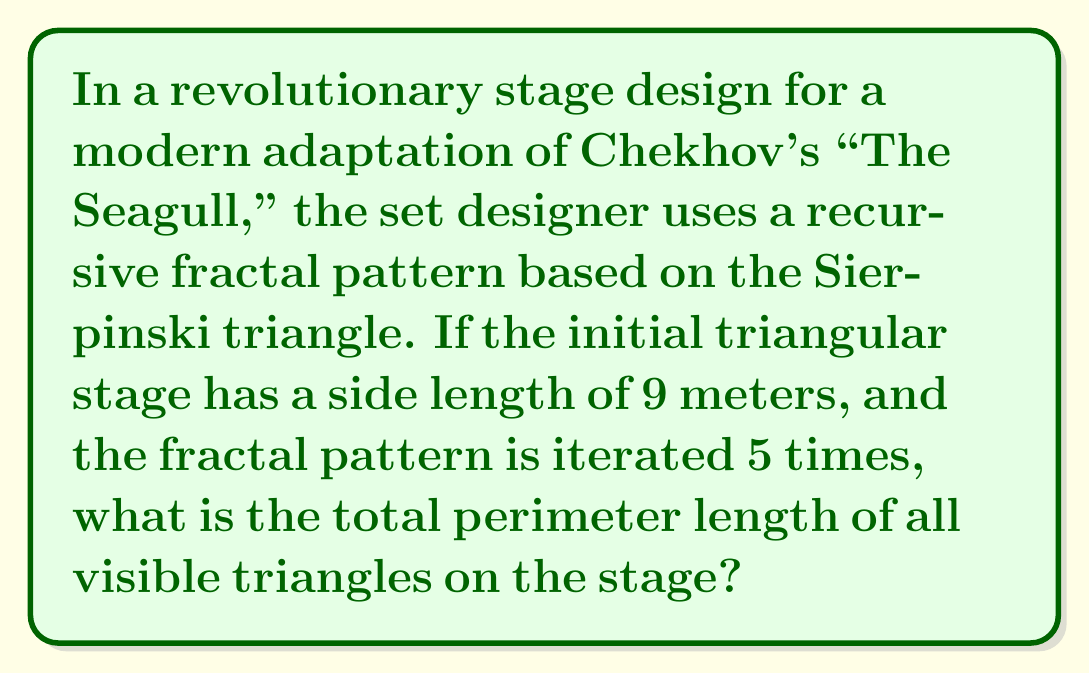Teach me how to tackle this problem. Let's approach this step-by-step:

1) The Sierpinski triangle is created by repeatedly removing the central triangle from each existing triangle.

2) In each iteration, the number of triangles triples, while their side length halves.

3) Let's calculate the number of triangles and their side lengths for each iteration:
   Iteration 0: 1 triangle, side length 9 m
   Iteration 1: 3 triangles, side length 4.5 m
   Iteration 2: 9 triangles, side length 2.25 m
   Iteration 3: 27 triangles, side length 1.125 m
   Iteration 4: 81 triangles, side length 0.5625 m
   Iteration 5: 243 triangles, side length 0.28125 m

4) The total number of triangles after 5 iterations is:
   $$ N = 1 + 3 + 9 + 27 + 81 + 243 = 364 $$

5) The perimeter of a single triangle at each iteration is:
   Iteration 0: $9 * 3 = 27$ m
   Iteration 1: $4.5 * 3 = 13.5$ m
   Iteration 2: $2.25 * 3 = 6.75$ m
   Iteration 3: $1.125 * 3 = 3.375$ m
   Iteration 4: $0.5625 * 3 = 1.6875$ m
   Iteration 5: $0.28125 * 3 = 0.84375$ m

6) The total perimeter is the sum of all these perimeters:
   $$ P = 27 + (3 * 13.5) + (9 * 6.75) + (27 * 3.375) + (81 * 1.6875) + (243 * 0.84375) $$

7) Simplifying:
   $$ P = 27 + 40.5 + 60.75 + 91.125 + 136.6875 + 205.03125 $$
   $$ P = 561.09375 \text{ meters} $$
Answer: 561.09375 m 